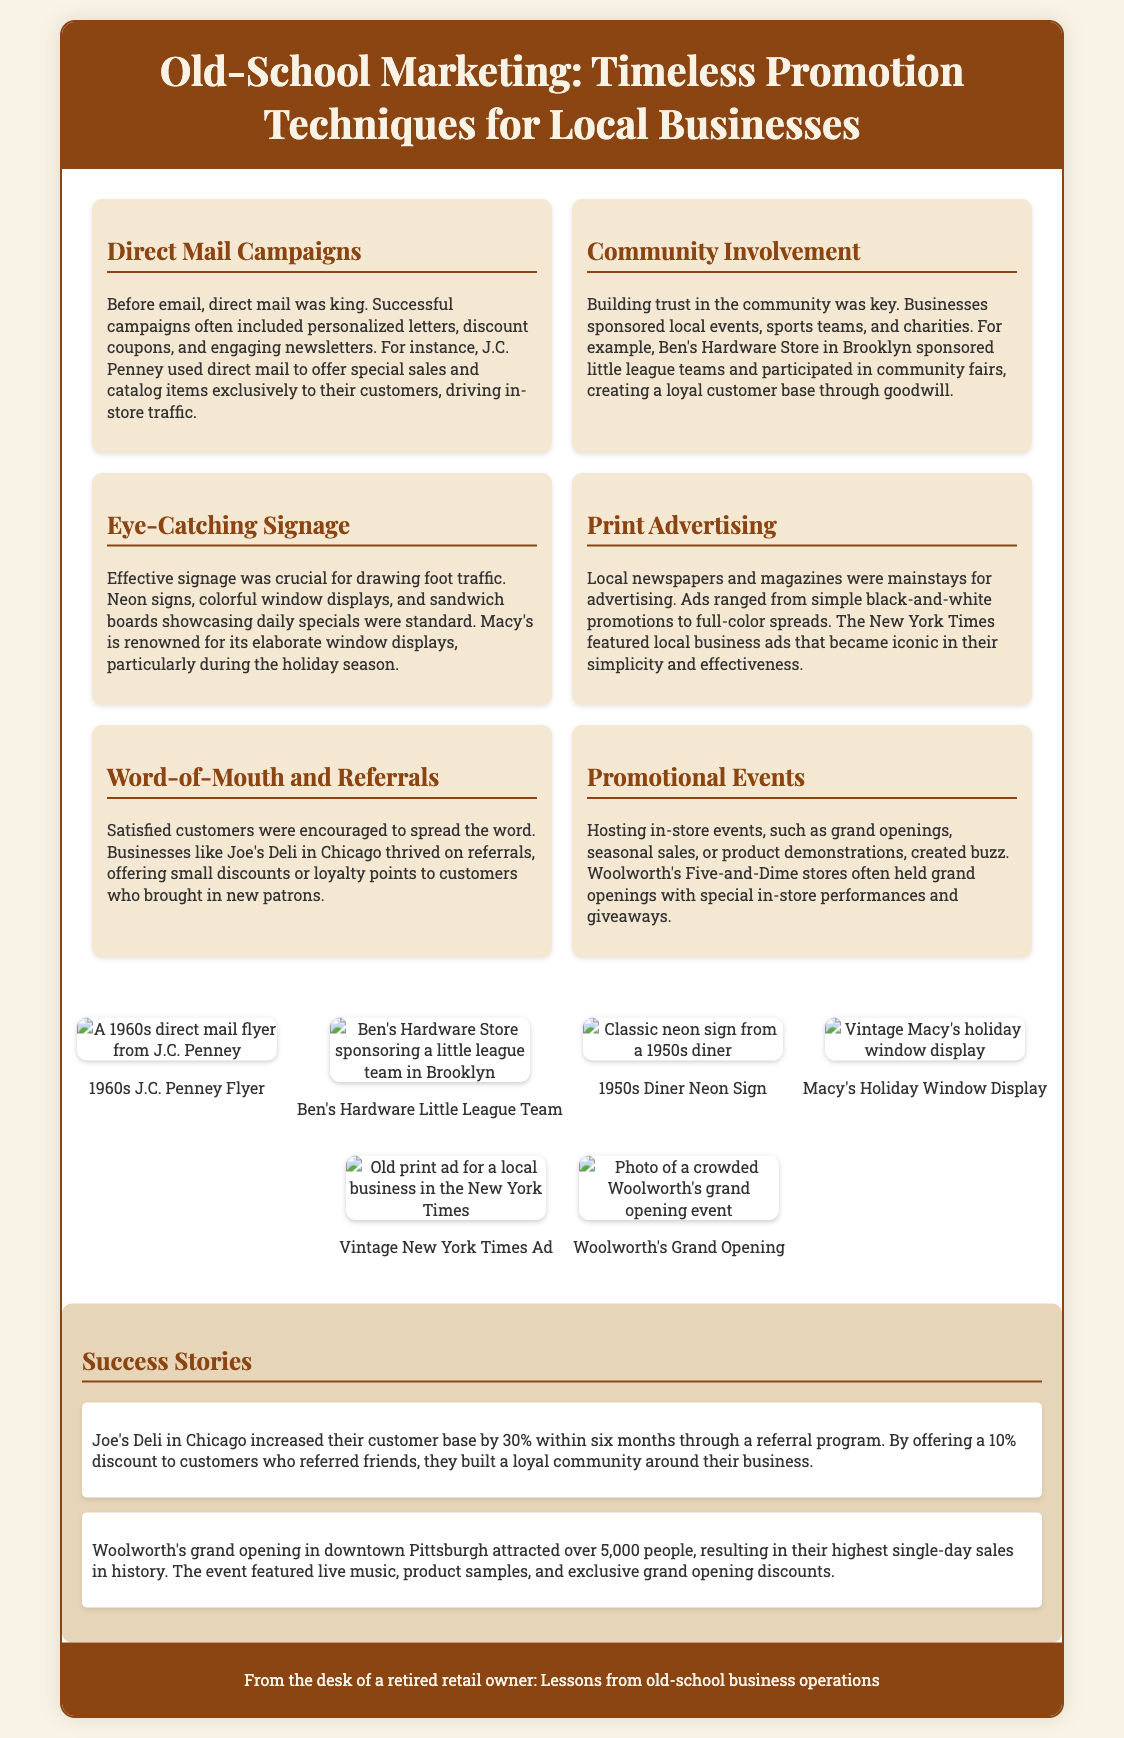What is the title of the flyer? The title is prominently displayed at the top of the document, stating the focus on old-school marketing techniques.
Answer: Old-School Marketing: Timeless Promotion Techniques for Local Businesses Which business sponsored little league teams? The document provides a specific example of a business that actively participated in community events.
Answer: Ben's Hardware Store What type of advertising is discussed as crucial for drawing foot traffic? The flyer mentions a specific method of advertising that was effective in attracting customers to physical locations.
Answer: Eye-Catching Signage What was a successful promotional event held by Woolworth's? The document highlights a particular event that attracted significant interest and sales for Woolworth's.
Answer: Grand Opening How much of an increase in customers did Joe's Deli achieve through referrals? This information is found in the success stories section of the document related to customer acquisition.
Answer: 30% What percentage discount did Joe's Deli offer for referrals? The flyer specifies the incentive provided to encourage customers to refer new patrons to the business.
Answer: 10% 